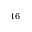<formula> <loc_0><loc_0><loc_500><loc_500>^ { 1 6 }</formula> 